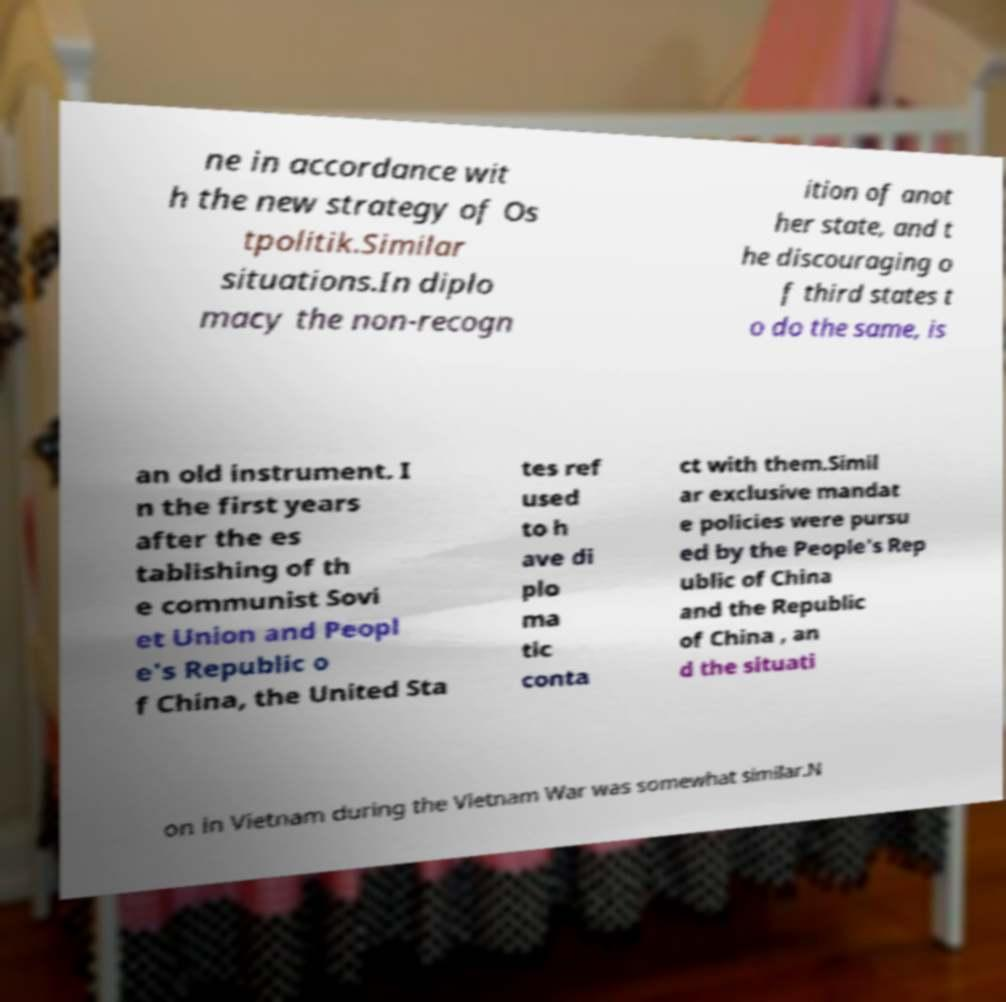What messages or text are displayed in this image? I need them in a readable, typed format. ne in accordance wit h the new strategy of Os tpolitik.Similar situations.In diplo macy the non-recogn ition of anot her state, and t he discouraging o f third states t o do the same, is an old instrument. I n the first years after the es tablishing of th e communist Sovi et Union and Peopl e's Republic o f China, the United Sta tes ref used to h ave di plo ma tic conta ct with them.Simil ar exclusive mandat e policies were pursu ed by the People's Rep ublic of China and the Republic of China , an d the situati on in Vietnam during the Vietnam War was somewhat similar.N 